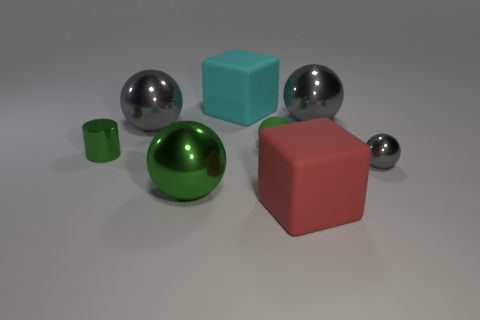Subtract all red blocks. How many gray balls are left? 3 Subtract all small green rubber balls. How many balls are left? 4 Subtract all red balls. Subtract all green cubes. How many balls are left? 5 Add 2 green balls. How many objects exist? 10 Subtract all cylinders. How many objects are left? 7 Add 4 green rubber blocks. How many green rubber blocks exist? 4 Subtract 0 brown cylinders. How many objects are left? 8 Subtract all small purple cylinders. Subtract all big cyan things. How many objects are left? 7 Add 1 cylinders. How many cylinders are left? 2 